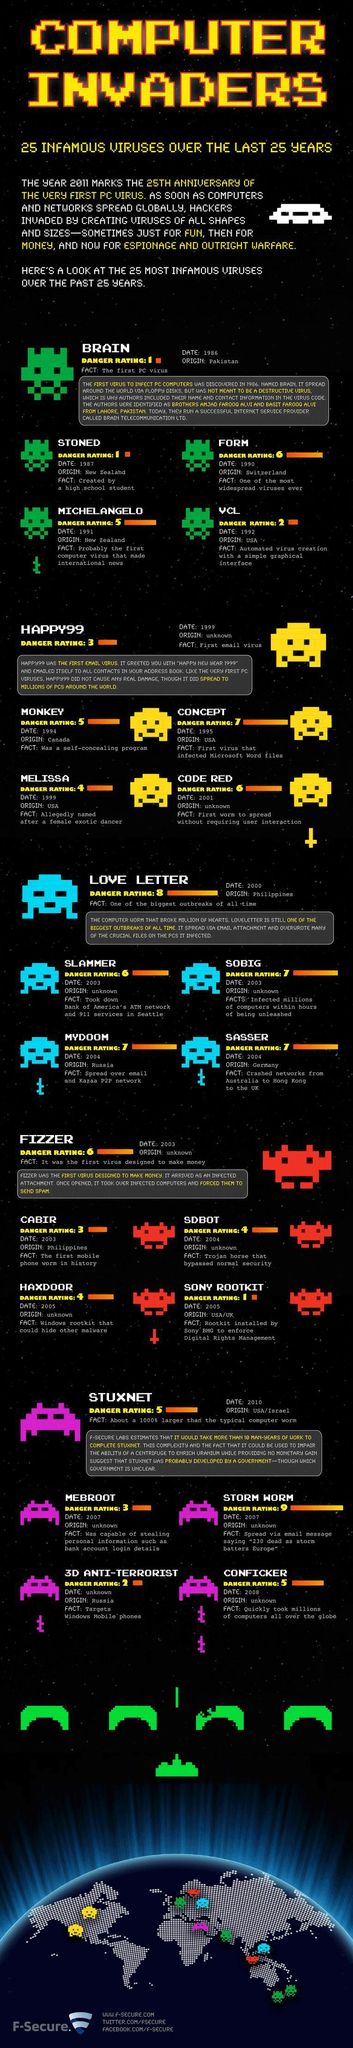Mention a couple of crucial points in this snapshot. Please list the names of viruses that have a danger rating of 2, including VCL and Anti-Terrorist. The following viruses have a danger rating of 3: Happy99, Cabir, and Mebroot. I want to know the number of viruses that have a danger rating of 6 out of 4. The number of viruses with a danger rating of 7 is 4. 